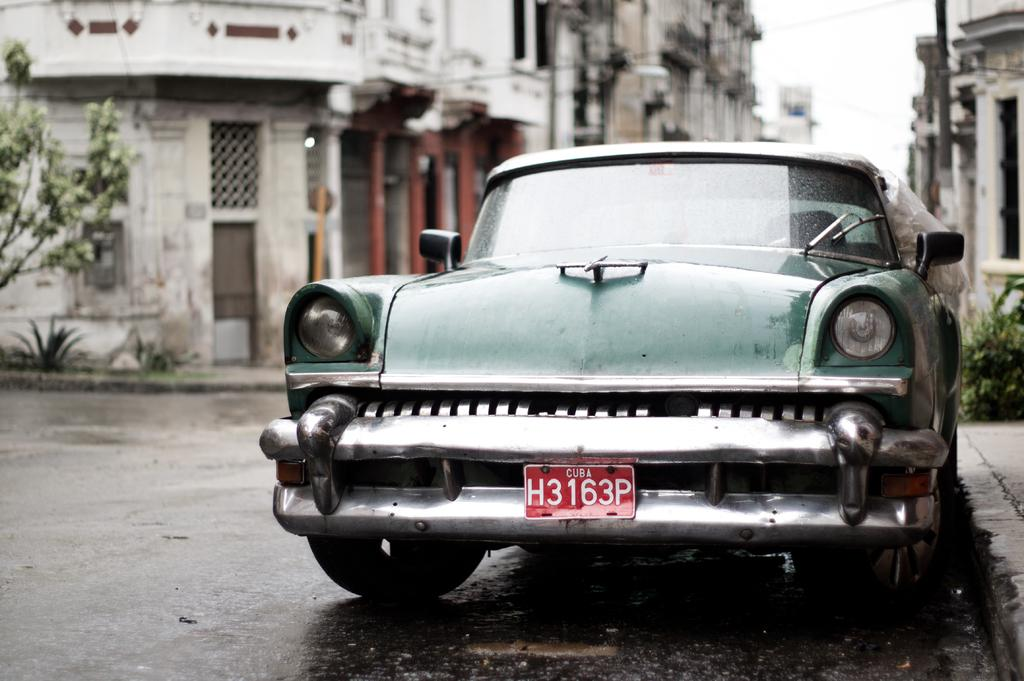What is the main subject of the image? There is a car on the road in the image. What else can be seen in the image besides the car? There is a building, a pole, trees, plants, and the sky visible in the image. How many bears are visible in the image? There are no bears present in the image. What type of goat can be seen on the pole in the image? There is no goat present on the pole or anywhere else in the image. 